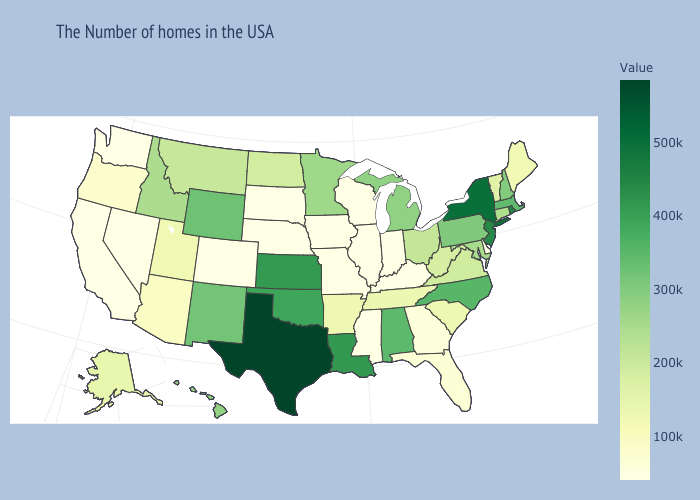Which states have the highest value in the USA?
Be succinct. Texas. Does Missouri have the lowest value in the MidWest?
Concise answer only. Yes. Is the legend a continuous bar?
Concise answer only. Yes. Does New Mexico have a higher value than Virginia?
Quick response, please. Yes. Which states have the lowest value in the USA?
Give a very brief answer. Delaware, Kentucky, Indiana, Wisconsin, Illinois, Mississippi, Missouri, Iowa, Nebraska, South Dakota, Colorado, Nevada, California, Washington. Does Iowa have the lowest value in the MidWest?
Be succinct. Yes. Is the legend a continuous bar?
Keep it brief. Yes. 